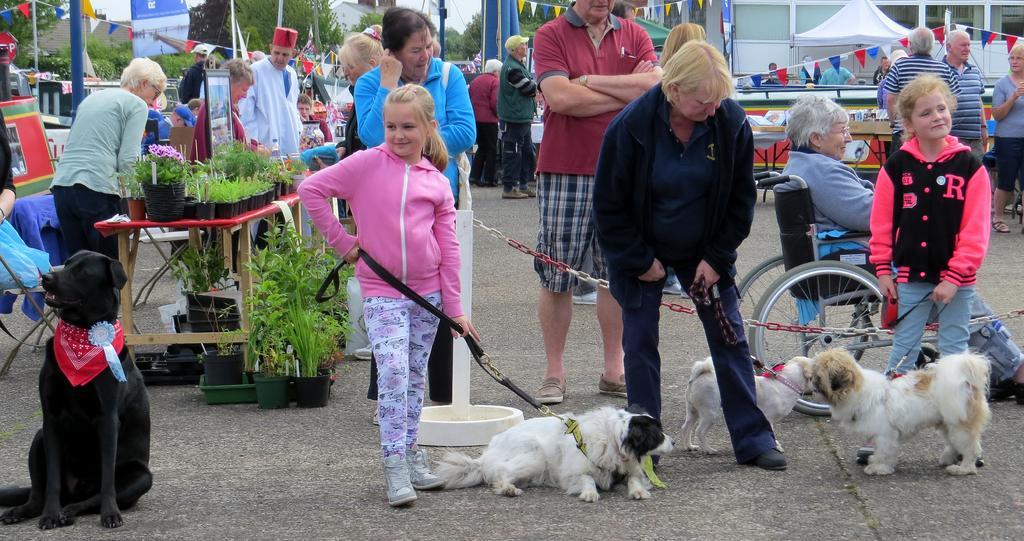Please provide a concise description of this image. As we can see in the image there are few people here and there, plants, dogs, wheelchair, table, buildings, trees and sky. 